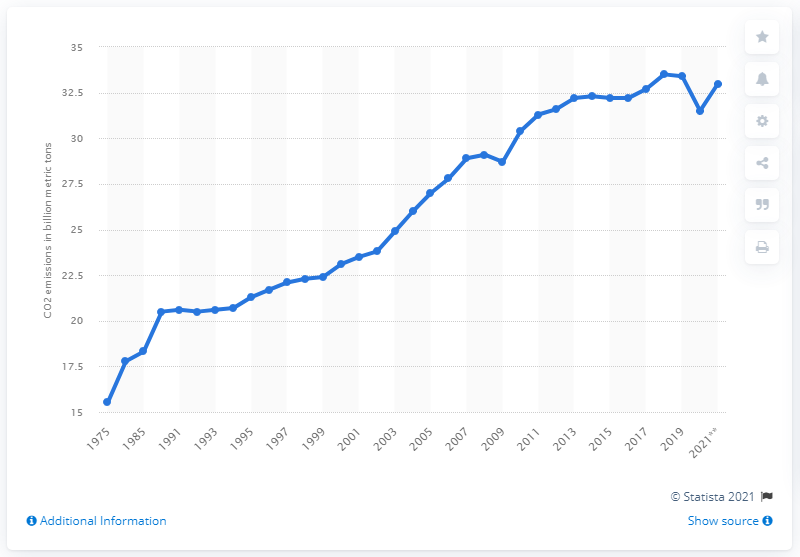Mention a couple of crucial points in this snapshot. In 2020, the global emissions of energy-related carbon dioxide were 31.5... 